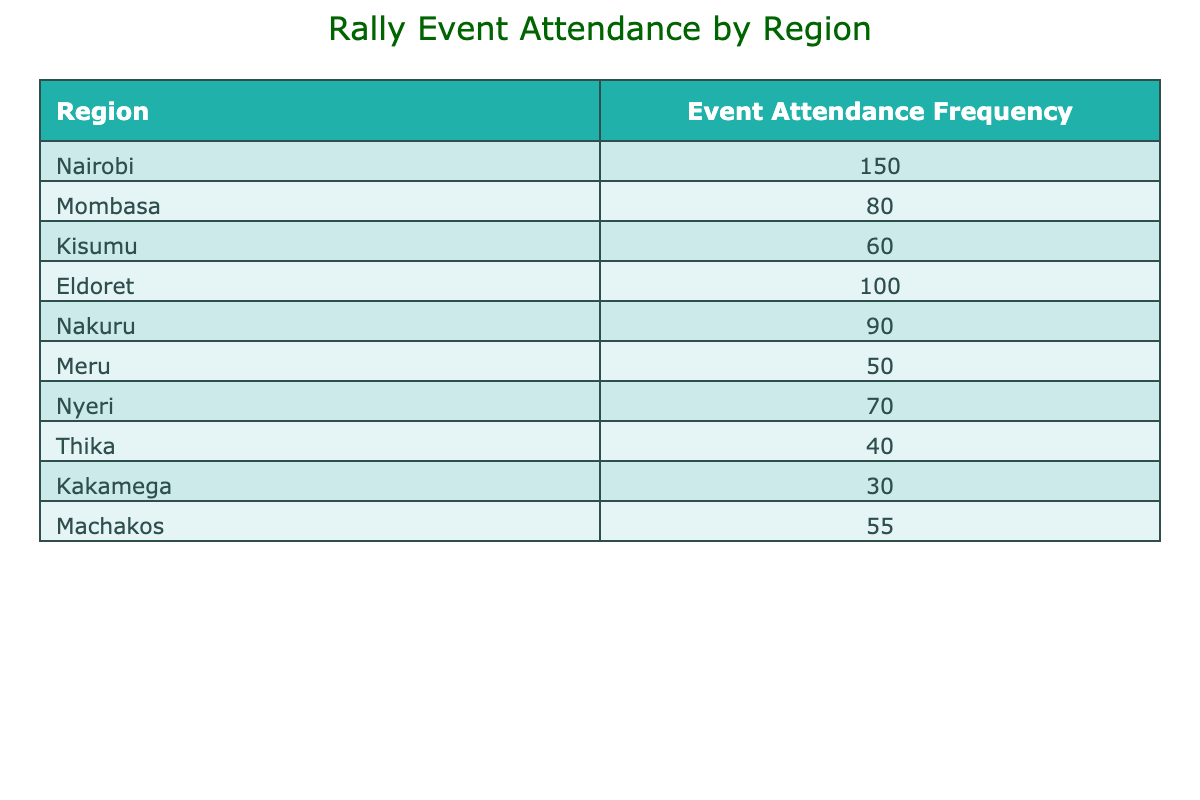What is the most attended region for rally events? By examining the table, we can see that the highest value in the "Event Attendance Frequency" column is 150, which corresponds to the "Nairobi" region. This indicates that Nairobi has the highest attendance at rally events.
Answer: Nairobi How many regions have an attendance frequency greater than 70? Looking through the table, we identify the regions with frequencies over 70: Nairobi (150), Eldoret (100), Nakuru (90), Nyeri (70), and Mombasa (80). Counting these, there are five regions that meet the criteria.
Answer: 5 What is the total event attendance frequency for all regions? To find the total, we sum the attendance frequencies of all regions: 150 (Nairobi) + 80 (Mombasa) + 60 (Kisumu) + 100 (Eldoret) + 90 (Nakuru) + 50 (Meru) + 70 (Nyeri) + 40 (Thika) + 30 (Kakamega) + 55 (Machakos) = 725. Thus, the total attendance frequency across all regions is 725.
Answer: 725 Is there a region with an attendance frequency of 30? By checking the "Event Attendance Frequency" column, we see that Kakamega has an attendance frequency of 30. Therefore, the answer to the question is yes, there is a region that fits this criterion.
Answer: Yes What is the average attendance frequency across all regions? To calculate the average, we first sum the attendance frequencies to get 725, then we divide by the number of regions, which is 10. The average is 725 divided by 10, resulting in 72.5. Therefore, the average attendance frequency across all regions is 72.5.
Answer: 72.5 Which region has the lowest event attendance frequency? In the "Event Attendance Frequency" column, the lowest value is 30, which corresponds to the Kakamega region. This identifies Kakamega as the region with the least event attendance frequency.
Answer: Kakamega How many regions have attendance frequencies between 50 and 100? Examining the table, we find the following regions with attendance frequencies in the range of 50 to 100: Kisumu (60), Eldoret (100), Nakuru (90), Meru (50), and Machakos (55). Summing these, we find there are five regions within this range.
Answer: 5 What is the difference in attendance frequency between the highest and the lowest? The highest attendance frequency is 150 (Nairobi) and the lowest is 30 (Kakamega). To find the difference, we subtract the lowest from the highest: 150 - 30 = 120. Thus, the difference in attendance frequency between the highest and lowest regions is 120.
Answer: 120 